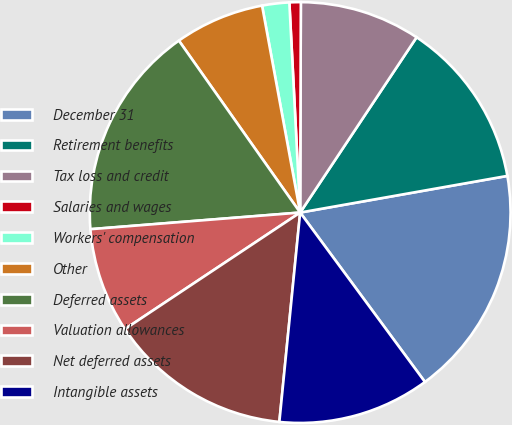Convert chart. <chart><loc_0><loc_0><loc_500><loc_500><pie_chart><fcel>December 31<fcel>Retirement benefits<fcel>Tax loss and credit<fcel>Salaries and wages<fcel>Workers' compensation<fcel>Other<fcel>Deferred assets<fcel>Valuation allowances<fcel>Net deferred assets<fcel>Intangible assets<nl><fcel>17.68%<fcel>12.88%<fcel>9.28%<fcel>0.87%<fcel>2.08%<fcel>6.88%<fcel>16.48%<fcel>8.08%<fcel>14.08%<fcel>11.68%<nl></chart> 